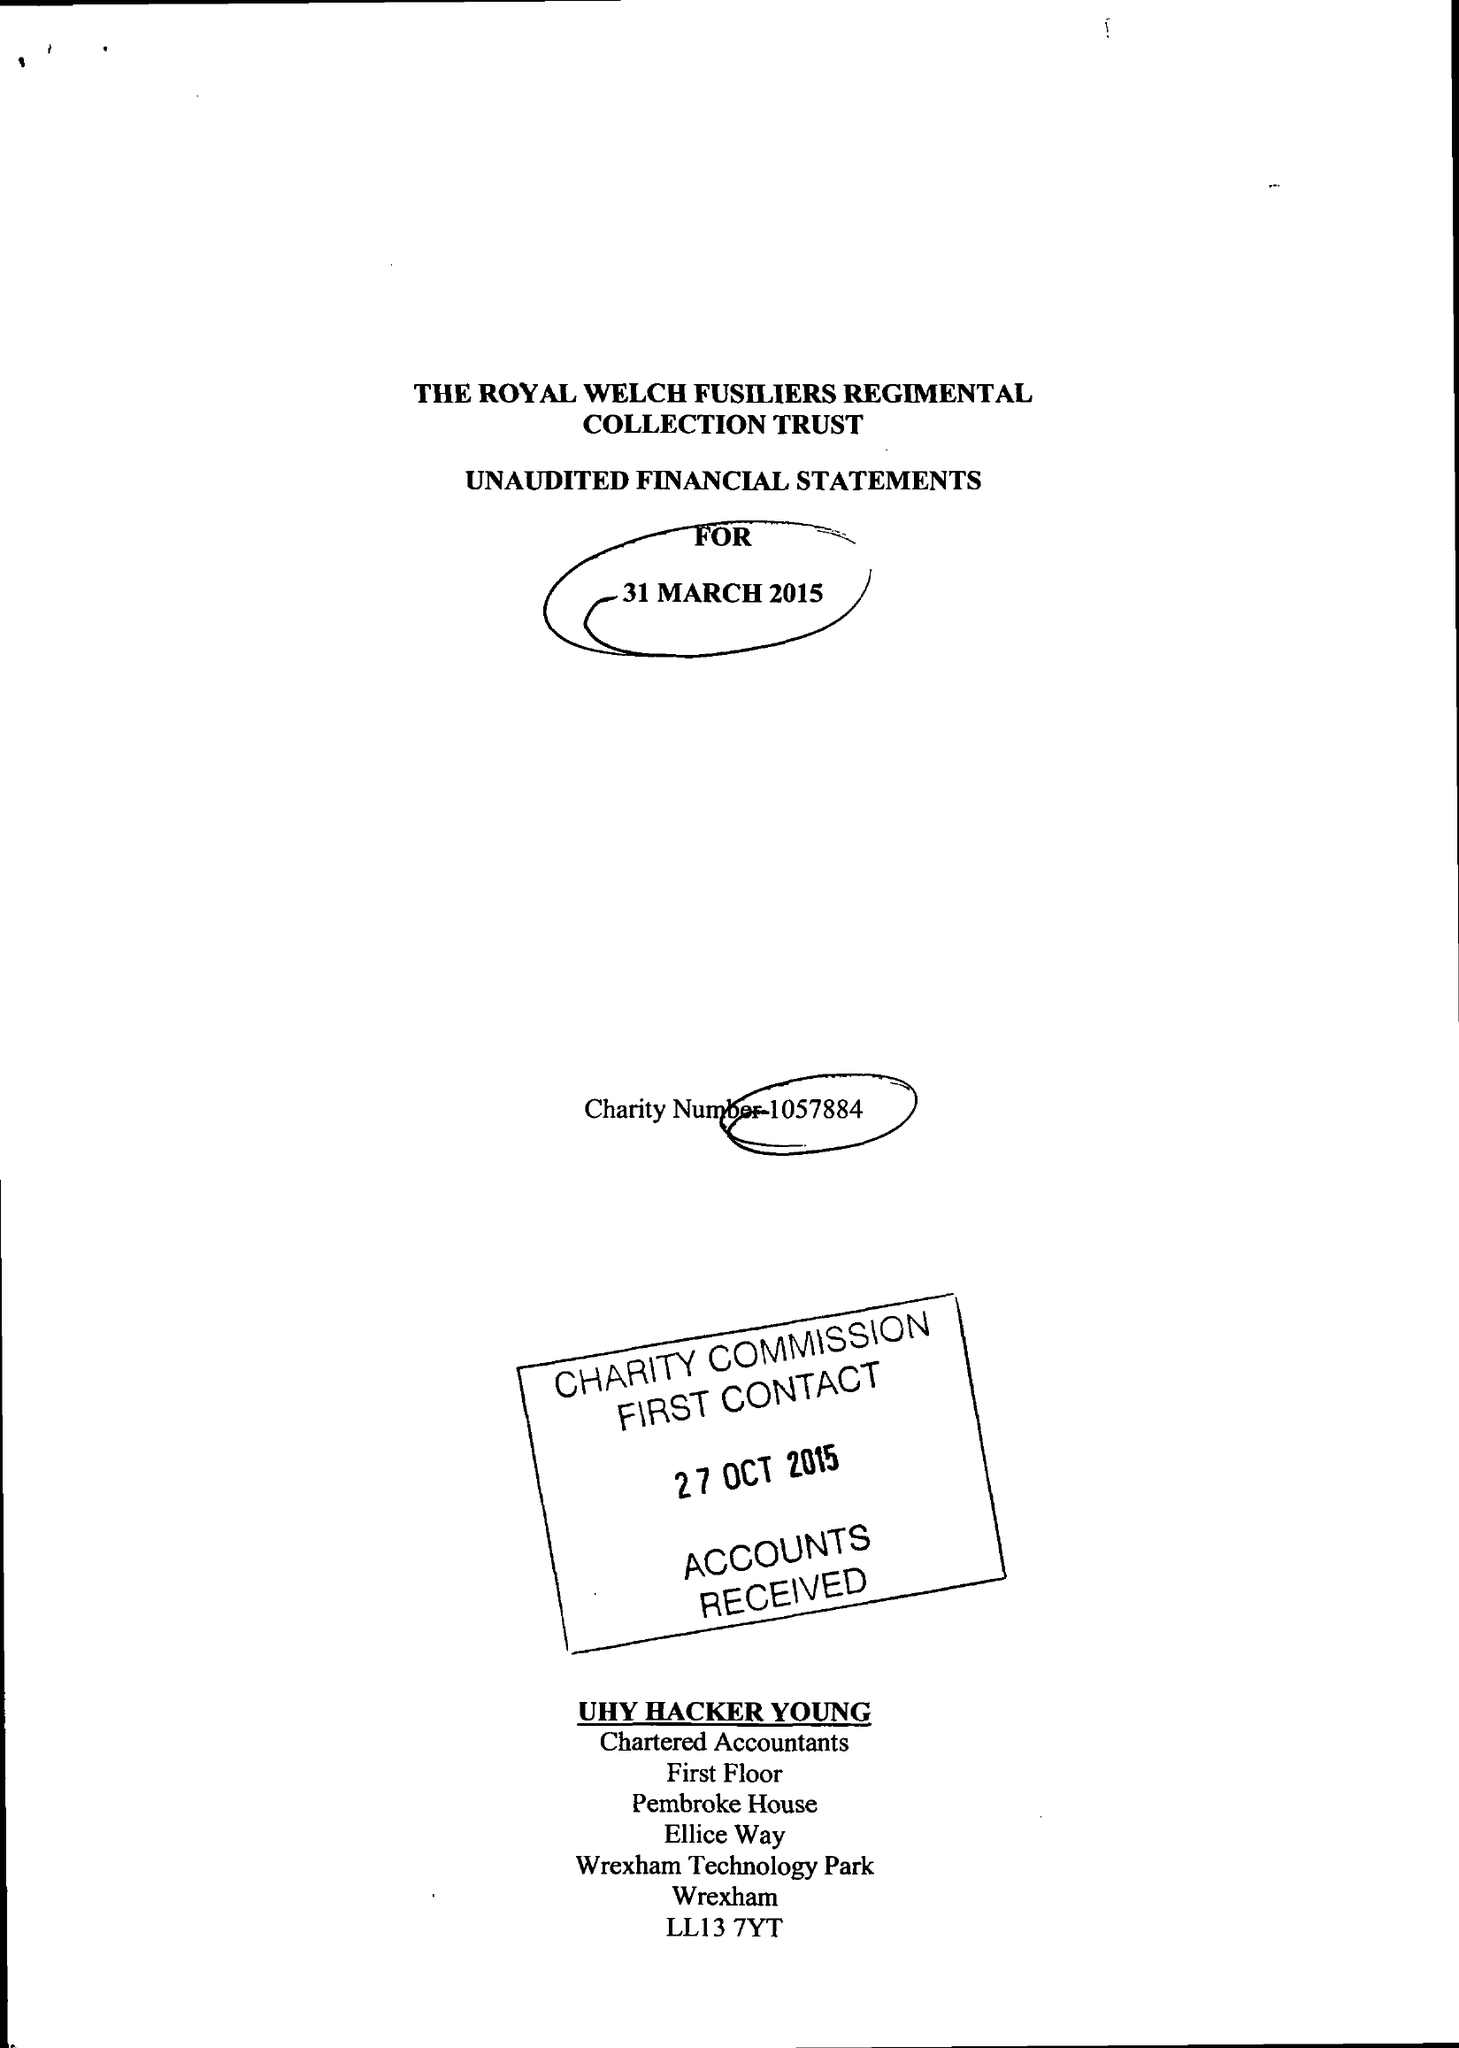What is the value for the report_date?
Answer the question using a single word or phrase. 2015-03-31 